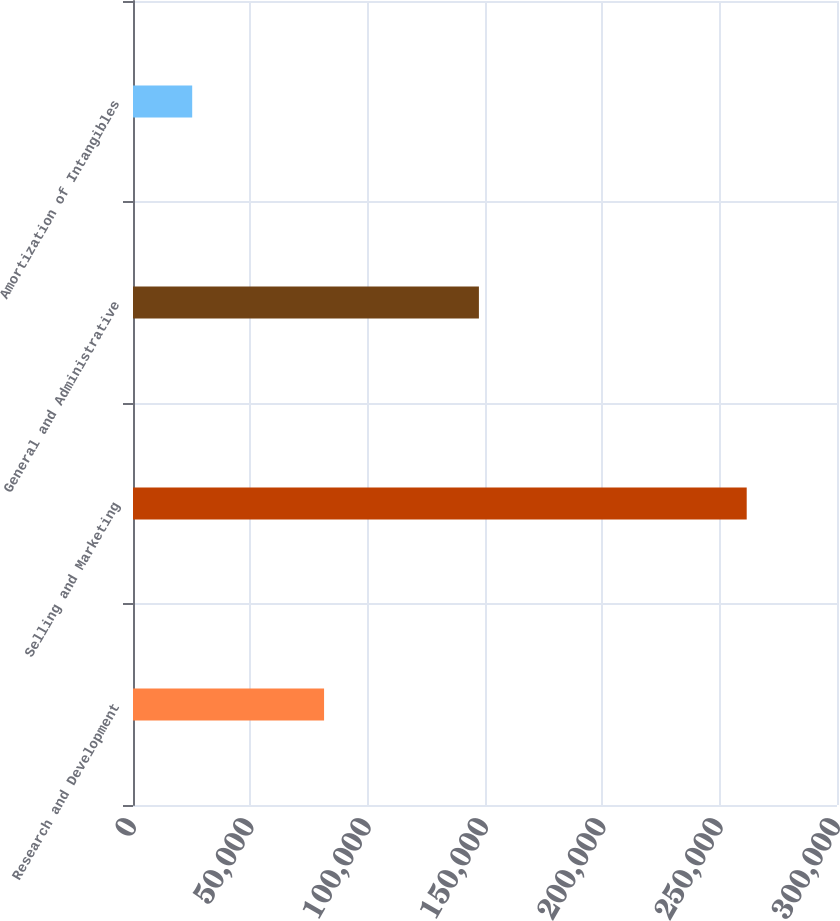<chart> <loc_0><loc_0><loc_500><loc_500><bar_chart><fcel>Research and Development<fcel>Selling and Marketing<fcel>General and Administrative<fcel>Amortization of Intangibles<nl><fcel>81421<fcel>261524<fcel>147405<fcel>25227<nl></chart> 